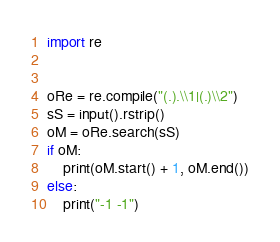Convert code to text. <code><loc_0><loc_0><loc_500><loc_500><_Python_>import re


oRe = re.compile("(.).\\1|(.)\\2")
sS = input().rstrip()
oM = oRe.search(sS)
if oM:
    print(oM.start() + 1, oM.end())
else:
    print("-1 -1")
</code> 